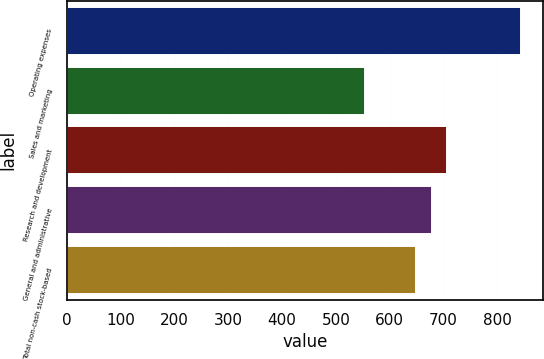Convert chart to OTSL. <chart><loc_0><loc_0><loc_500><loc_500><bar_chart><fcel>Operating expenses<fcel>Sales and marketing<fcel>Research and development<fcel>General and administrative<fcel>Total non-cash stock-based<nl><fcel>843<fcel>554<fcel>706.8<fcel>677.9<fcel>649<nl></chart> 